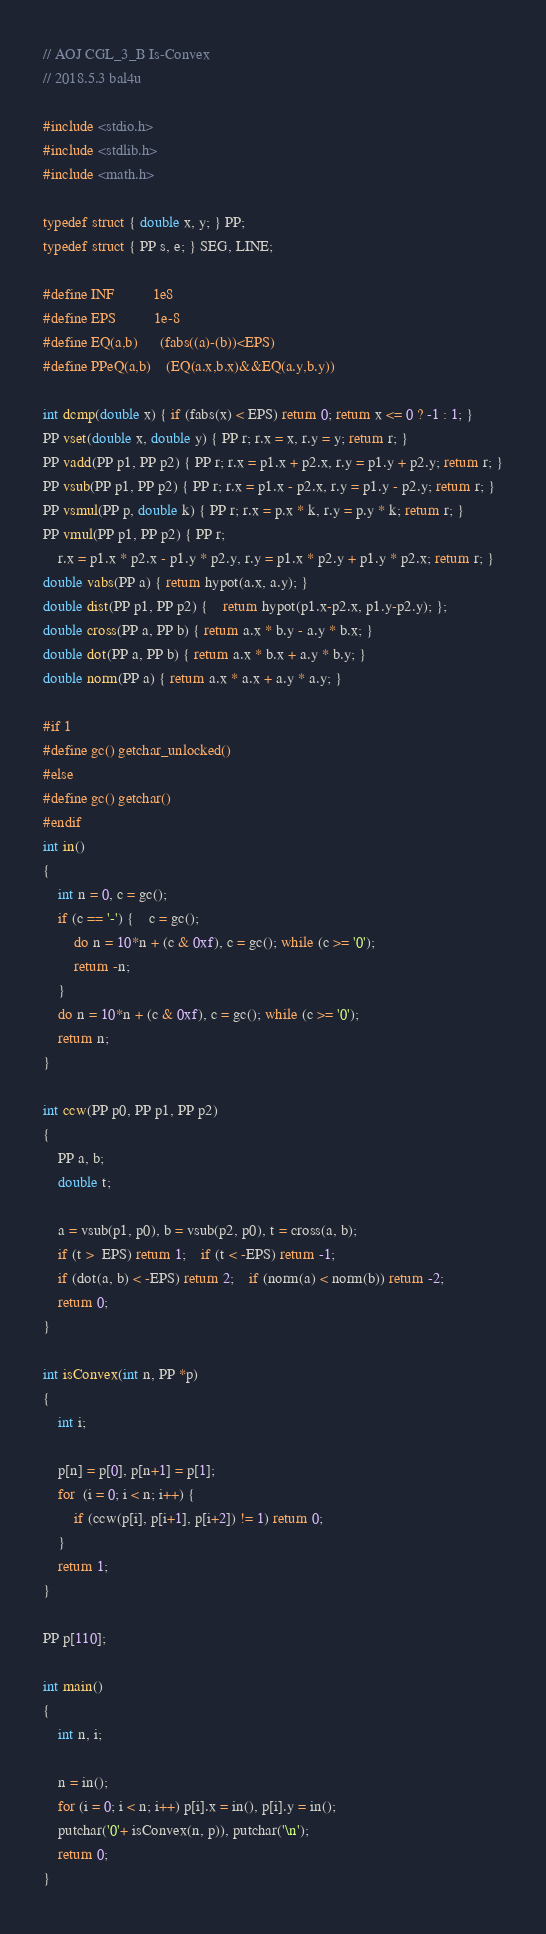Convert code to text. <code><loc_0><loc_0><loc_500><loc_500><_C_>// AOJ CGL_3_B Is-Convex
// 2018.5.3 bal4u

#include <stdio.h>
#include <stdlib.h>
#include <math.h>

typedef struct { double x, y; } PP;
typedef struct { PP s, e; } SEG, LINE;

#define INF			1e8
#define EPS			1e-8
#define EQ(a,b)		(fabs((a)-(b))<EPS)
#define PPeQ(a,b)	(EQ(a.x,b.x)&&EQ(a.y,b.y))

int dcmp(double x) { if (fabs(x) < EPS) return 0; return x <= 0 ? -1 : 1; }
PP vset(double x, double y) { PP r; r.x = x, r.y = y; return r; }
PP vadd(PP p1, PP p2) { PP r; r.x = p1.x + p2.x, r.y = p1.y + p2.y; return r; }
PP vsub(PP p1, PP p2) { PP r; r.x = p1.x - p2.x, r.y = p1.y - p2.y; return r; }
PP vsmul(PP p, double k) { PP r; r.x = p.x * k, r.y = p.y * k; return r; }
PP vmul(PP p1, PP p2) { PP r;
	r.x = p1.x * p2.x - p1.y * p2.y, r.y = p1.x * p2.y + p1.y * p2.x; return r; }
double vabs(PP a) { return hypot(a.x, a.y); }
double dist(PP p1, PP p2) {	return hypot(p1.x-p2.x, p1.y-p2.y); };
double cross(PP a, PP b) { return a.x * b.y - a.y * b.x; }
double dot(PP a, PP b) { return a.x * b.x + a.y * b.y; }
double norm(PP a) { return a.x * a.x + a.y * a.y; }

#if 1
#define gc() getchar_unlocked()
#else
#define gc() getchar()
#endif
int in()
{
	int n = 0, c = gc();
	if (c == '-') {	c = gc();
		do n = 10*n + (c & 0xf), c = gc(); while (c >= '0');
		return -n;
	}
	do n = 10*n + (c & 0xf), c = gc(); while (c >= '0');
	return n;
}

int ccw(PP p0, PP p1, PP p2)
{
	PP a, b;
	double t;

	a = vsub(p1, p0), b = vsub(p2, p0), t = cross(a, b);
	if (t >  EPS) return 1;	if (t < -EPS) return -1;
	if (dot(a, b) < -EPS) return 2;	if (norm(a) < norm(b)) return -2;
	return 0;
}

int isConvex(int n, PP *p)
{
	int i;

	p[n] = p[0], p[n+1] = p[1];
	for  (i = 0; i < n; i++) {
		if (ccw(p[i], p[i+1], p[i+2]) != 1) return 0;
	}
	return 1;
}

PP p[110];

int main()
{
	int n, i;

	n = in();
	for (i = 0; i < n; i++) p[i].x = in(), p[i].y = in();
	putchar('0'+ isConvex(n, p)), putchar('\n');
	return 0;
}

</code> 